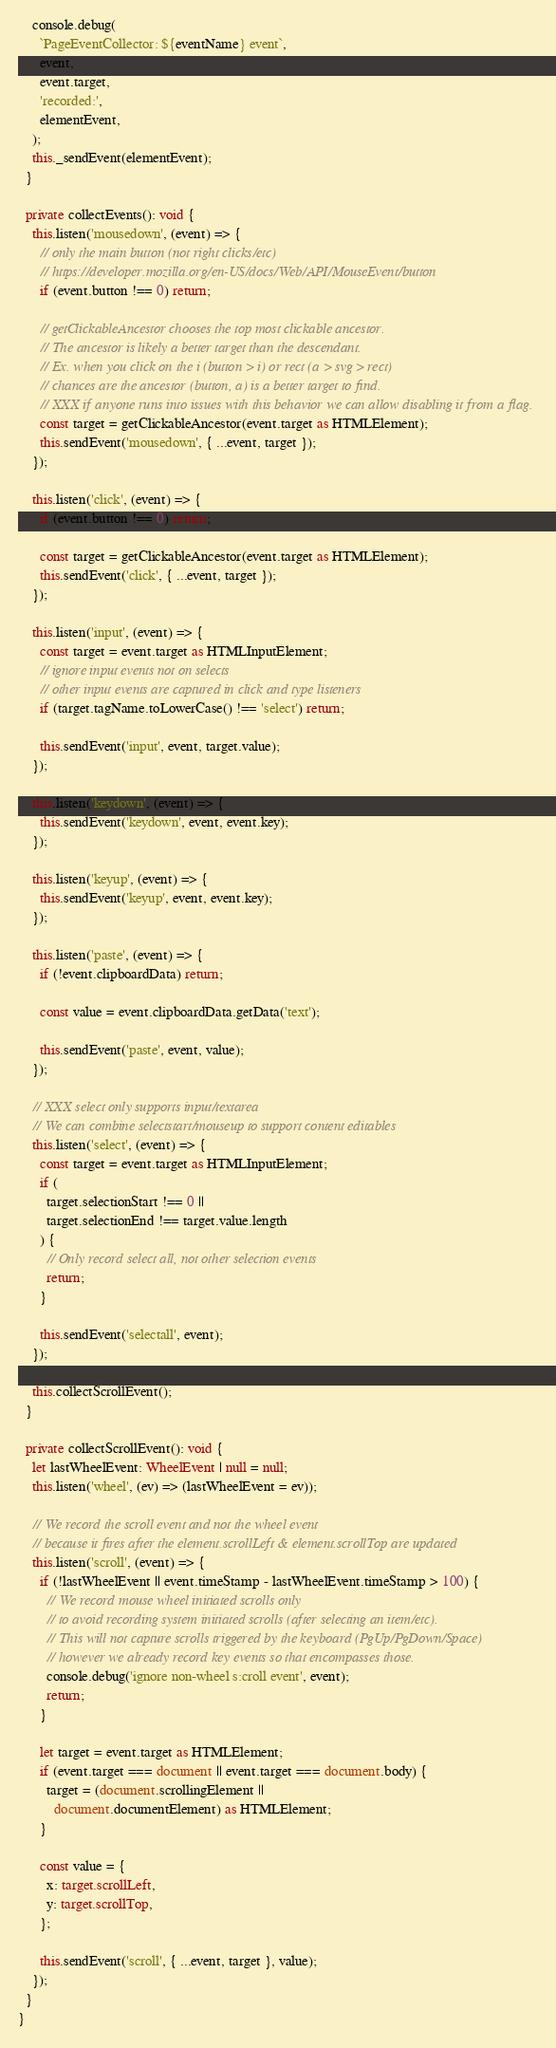Convert code to text. <code><loc_0><loc_0><loc_500><loc_500><_TypeScript_>
    console.debug(
      `PageEventCollector: ${eventName} event`,
      event,
      event.target,
      'recorded:',
      elementEvent,
    );
    this._sendEvent(elementEvent);
  }

  private collectEvents(): void {
    this.listen('mousedown', (event) => {
      // only the main button (not right clicks/etc)
      // https://developer.mozilla.org/en-US/docs/Web/API/MouseEvent/button
      if (event.button !== 0) return;

      // getClickableAncestor chooses the top most clickable ancestor.
      // The ancestor is likely a better target than the descendant.
      // Ex. when you click on the i (button > i) or rect (a > svg > rect)
      // chances are the ancestor (button, a) is a better target to find.
      // XXX if anyone runs into issues with this behavior we can allow disabling it from a flag.
      const target = getClickableAncestor(event.target as HTMLElement);
      this.sendEvent('mousedown', { ...event, target });
    });

    this.listen('click', (event) => {
      if (event.button !== 0) return;

      const target = getClickableAncestor(event.target as HTMLElement);
      this.sendEvent('click', { ...event, target });
    });

    this.listen('input', (event) => {
      const target = event.target as HTMLInputElement;
      // ignore input events not on selects
      // other input events are captured in click and type listeners
      if (target.tagName.toLowerCase() !== 'select') return;

      this.sendEvent('input', event, target.value);
    });

    this.listen('keydown', (event) => {
      this.sendEvent('keydown', event, event.key);
    });

    this.listen('keyup', (event) => {
      this.sendEvent('keyup', event, event.key);
    });

    this.listen('paste', (event) => {
      if (!event.clipboardData) return;

      const value = event.clipboardData.getData('text');

      this.sendEvent('paste', event, value);
    });

    // XXX select only supports input/textarea
    // We can combine selectstart/mouseup to support content editables
    this.listen('select', (event) => {
      const target = event.target as HTMLInputElement;
      if (
        target.selectionStart !== 0 ||
        target.selectionEnd !== target.value.length
      ) {
        // Only record select all, not other selection events
        return;
      }

      this.sendEvent('selectall', event);
    });

    this.collectScrollEvent();
  }

  private collectScrollEvent(): void {
    let lastWheelEvent: WheelEvent | null = null;
    this.listen('wheel', (ev) => (lastWheelEvent = ev));

    // We record the scroll event and not the wheel event
    // because it fires after the element.scrollLeft & element.scrollTop are updated
    this.listen('scroll', (event) => {
      if (!lastWheelEvent || event.timeStamp - lastWheelEvent.timeStamp > 100) {
        // We record mouse wheel initiated scrolls only
        // to avoid recording system initiated scrolls (after selecting an item/etc).
        // This will not capture scrolls triggered by the keyboard (PgUp/PgDown/Space)
        // however we already record key events so that encompasses those.
        console.debug('ignore non-wheel s:croll event', event);
        return;
      }

      let target = event.target as HTMLElement;
      if (event.target === document || event.target === document.body) {
        target = (document.scrollingElement ||
          document.documentElement) as HTMLElement;
      }

      const value = {
        x: target.scrollLeft,
        y: target.scrollTop,
      };

      this.sendEvent('scroll', { ...event, target }, value);
    });
  }
}
</code> 